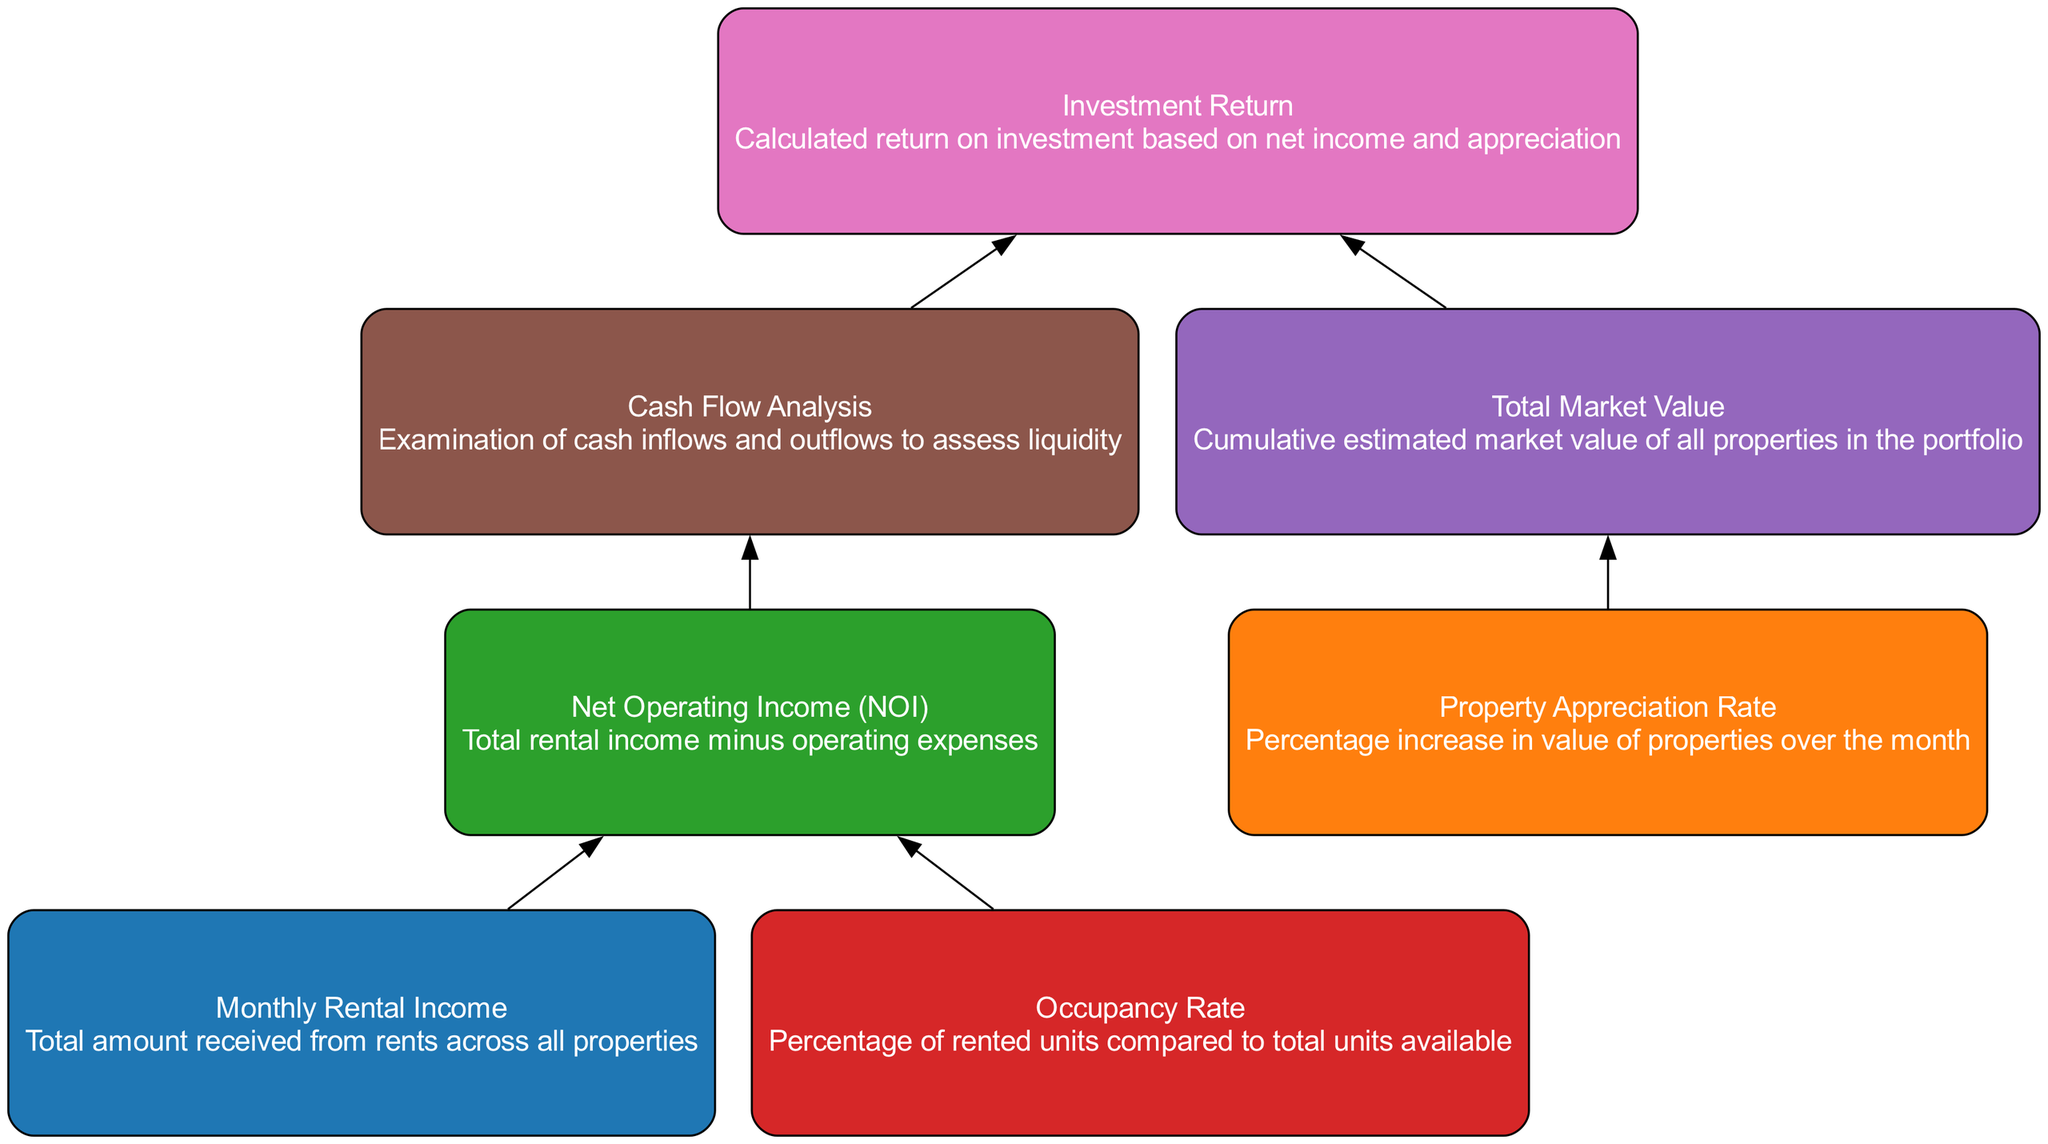What is the starting point of the flow chart? The flow chart begins with "Monthly Rental Income," which is the first element in the diagram. This element is depicted at the bottom, indicating its role as a base input for the subsequent calculations.
Answer: Monthly Rental Income How many nodes are present in the diagram? The diagram contains a total of 7 nodes, representing different aspects of the real estate portfolio's performance. Each node corresponds to a unique element detailed in the data structure.
Answer: 7 What does "Net Operating Income (NOI)" depend on? "Net Operating Income (NOI)" is calculated based on two inputs: "Monthly Rental Income" and "Occupancy Rate." Both of these nodes feed directly into the NOI, indicating their importance in determining it.
Answer: Monthly Rental Income and Occupancy Rate What is the relationship between "Total Market Value" and "Investment Return"? "Total Market Value" directly influences "Investment Return," as it is one of the inputs used in calculating the return on investment. This shows that a higher total market value can lead to a greater investment return.
Answer: Total Market Value Which node provides an analysis of cash inflows and outflows? The node "Cash Flow Analysis" represents the examination of cash inflows and outflows, which helps assess liquidity. This node is connected to "Net Operating Income (NOI)" and leads to "Investment Return."
Answer: Cash Flow Analysis Which elements impact "Investment Return"? "Investment Return" is influenced by three elements: "Cash Flow Analysis," "Total Market Value," and indirectly "Net Operating Income (NOI)". This requires looking back through the flows that lead into the investment return node.
Answer: Cash Flow Analysis, Total Market Value, Net Operating Income (NOI) What is the purpose of the "Occupancy Rate" node? The "Occupancy Rate" provides crucial data that contributes to calculating "Net Operating Income (NOI)." It indicates the percentage of rented units compared to the total, affecting overall income.
Answer: To assess the percentage of rented units and impact NOI What color is used for nodes in the diagram? The nodes in the diagram are filled with a color scheme that includes blue, orange, green, red, purple, brown, and pink. Each node is filled with a color selected from this predefined palette.
Answer: Blue, orange, green, red, purple, brown, pink 